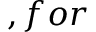<formula> <loc_0><loc_0><loc_500><loc_500>, f o r</formula> 